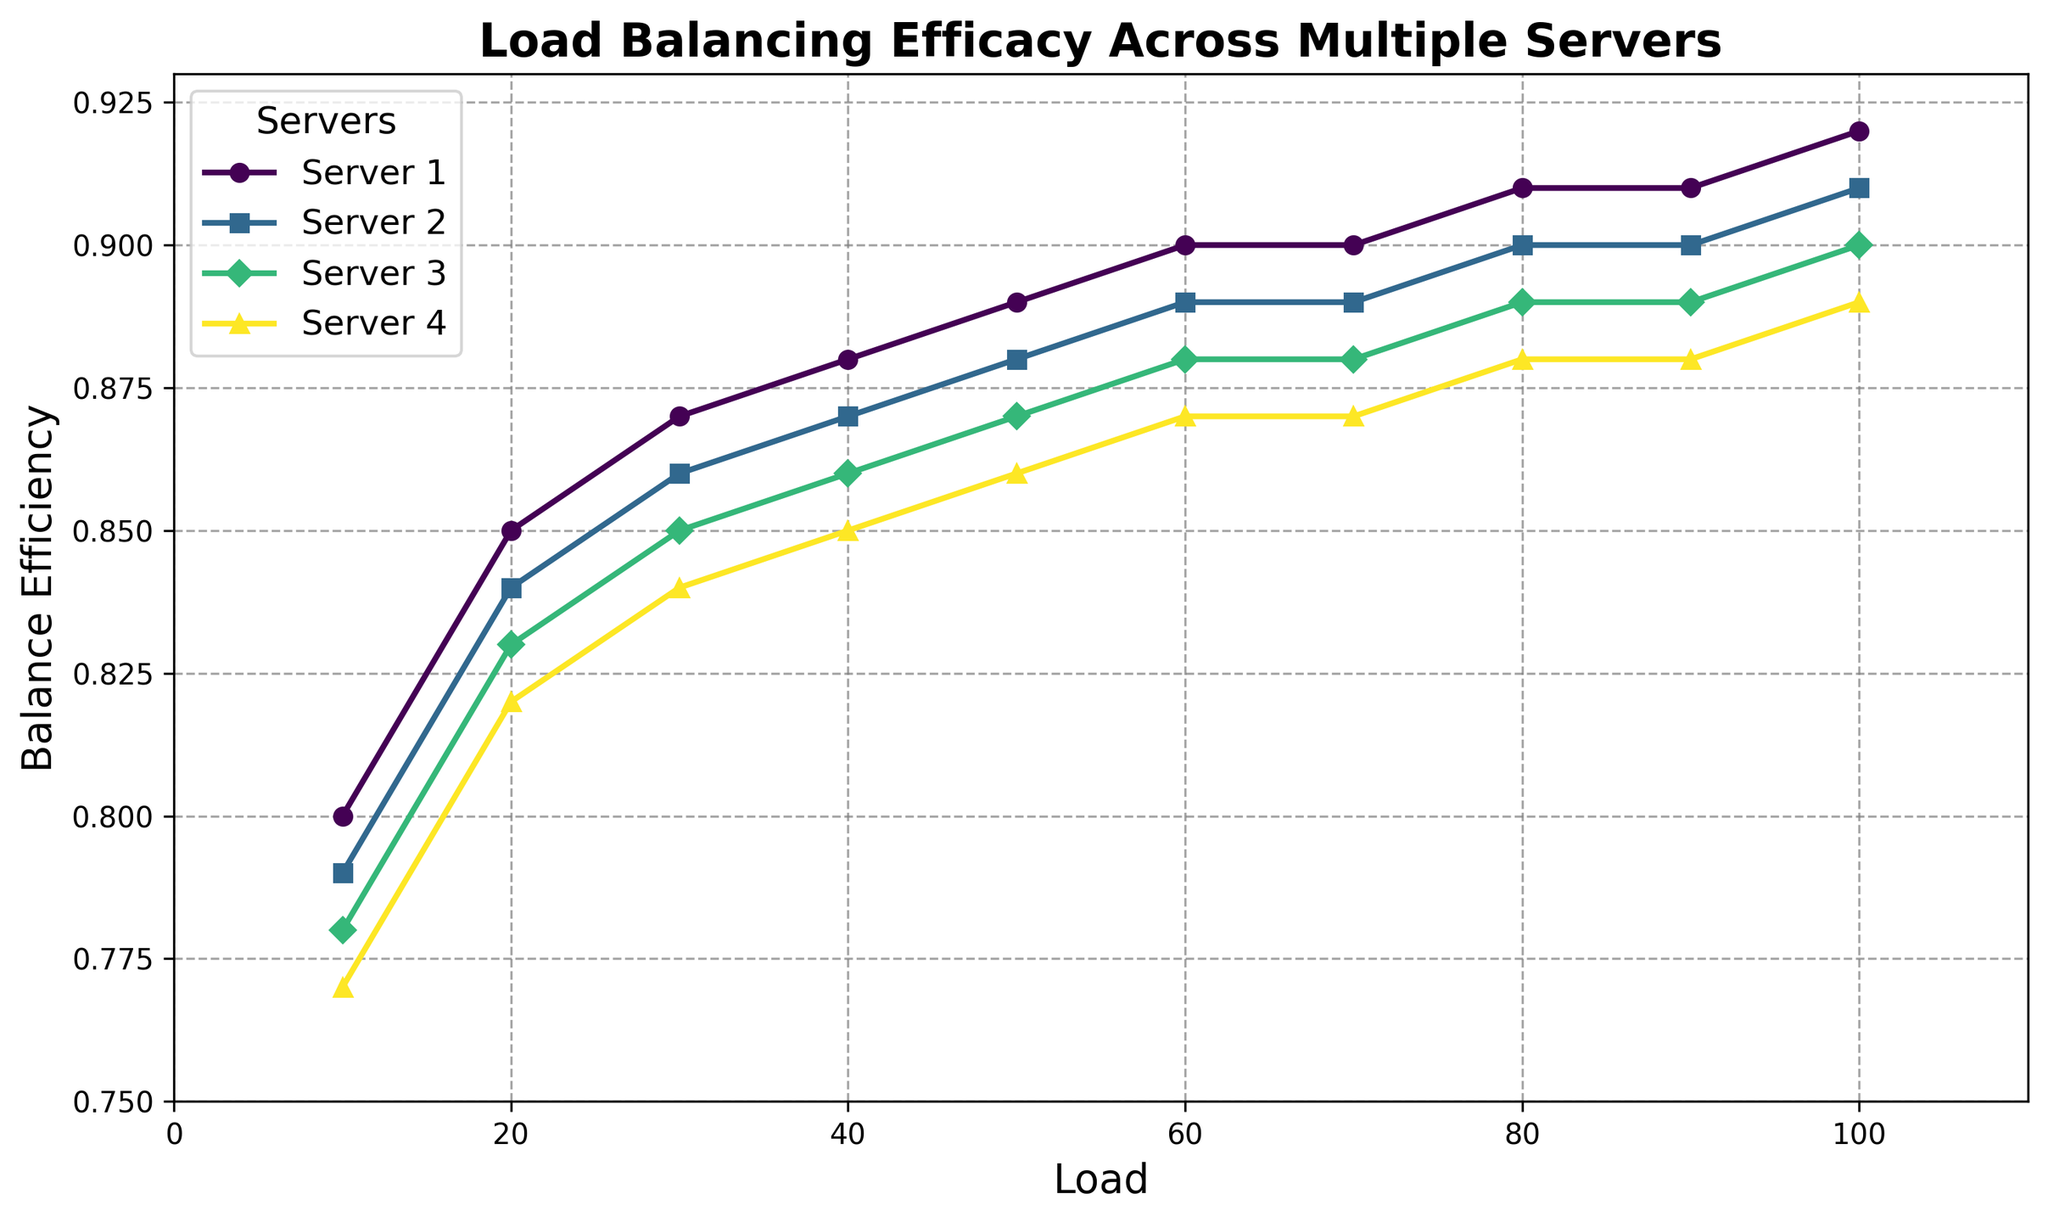What is the approximate balance efficiency for Server 3 at a load of 60? Locate the plot for Server 3. At a load of 60, look vertically to where it intersects with the Server 3 line, which is marked by a specific marker.
Answer: 0.88 Which server shows the highest balance efficiency at a load of 100? Look at the balance efficiency values at a load of 100 for all servers. Compare these values to find the highest one.
Answer: Server 1 By how much does the balance efficiency of Server 4 change from a load of 10 to a load of 100? Identify the balance efficiencies for Server 4 at loads of 10 and 100 from the graph. Then, subtract the value at load 10 from the value at load 100.
Answer: 0.12 Which server shows the least improvement in balance efficiency from a load of 10 to a load of 100? Calculate the change in balance efficiency from load 10 to 100 for each server. Compare the improvements and identify the smallest one.
Answer: Server 1 What is the average balance efficiency of Server 2 across all loads? Extract balance efficiency values for all loads for Server 2. Sum these values and divide by the number of data points (10 loads).
Answer: 0.87 Can you spot any server whose balance efficiency stabilizes after a certain load? If so, which one and at what load? Observe each server's balance efficiency plot and see if any server's efficiency values stabilize (flatten) after a certain load.
Answer: Server 1, at load 60 At a load of 50, which server performs the best in terms of balance efficiency? Locate the balance efficiency values for each server at a load of 50 and compare them to find the highest one.
Answer: Server 1 How does Server 2's balance efficiency at a load of 30 compare to Server 4's balance efficiency at the same load? Find the balance efficiency values for both Server 2 and Server 4 at a load of 30 and compare them to see which is higher.
Answer: Server 2 is higher Which server shows the smoothest (least variable) increase in balance efficiency as the load increases? Visually inspect the plots for each server and identify the one with the smoothest, most consistent upward trend without large jumps or drops.
Answer: Server 1 What is the difference in balance efficiency between Server 2 and Server 3 at a load of 20? Identify the balance efficiencies for Server 2 and Server 3 at a load of 20 and subtract one from the other.
Answer: 0.01 